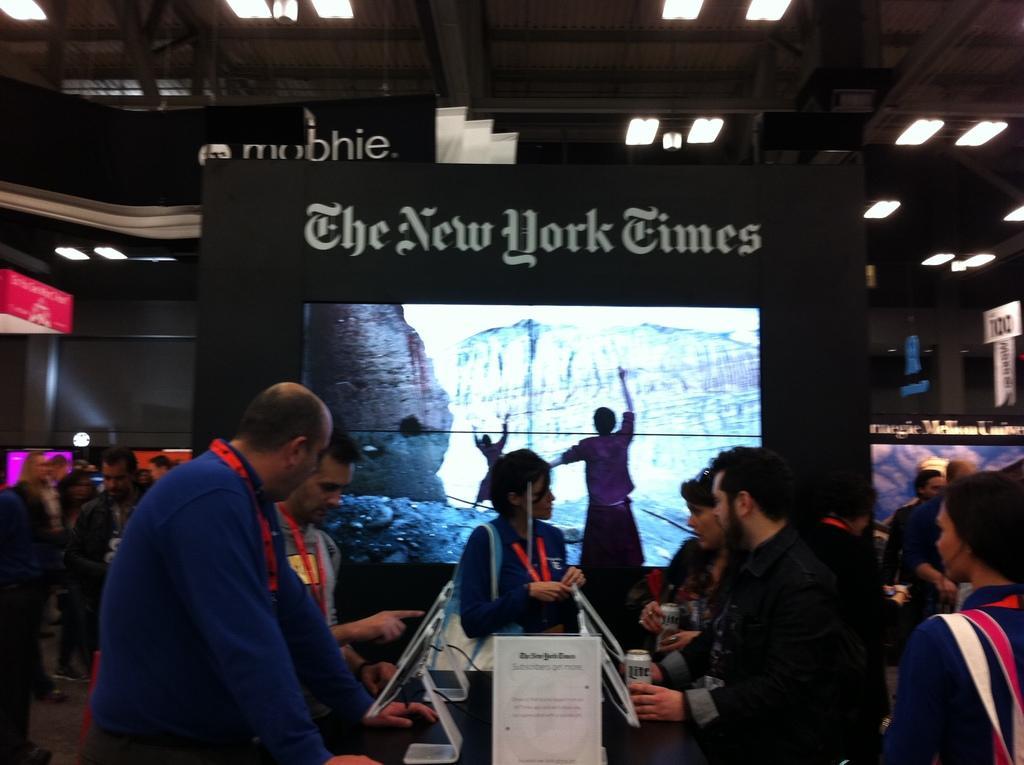Please provide a concise description of this image. In this image in the foreground there are some people standing and looking at something. and at the back there are some people standing and in the middle there a screen 